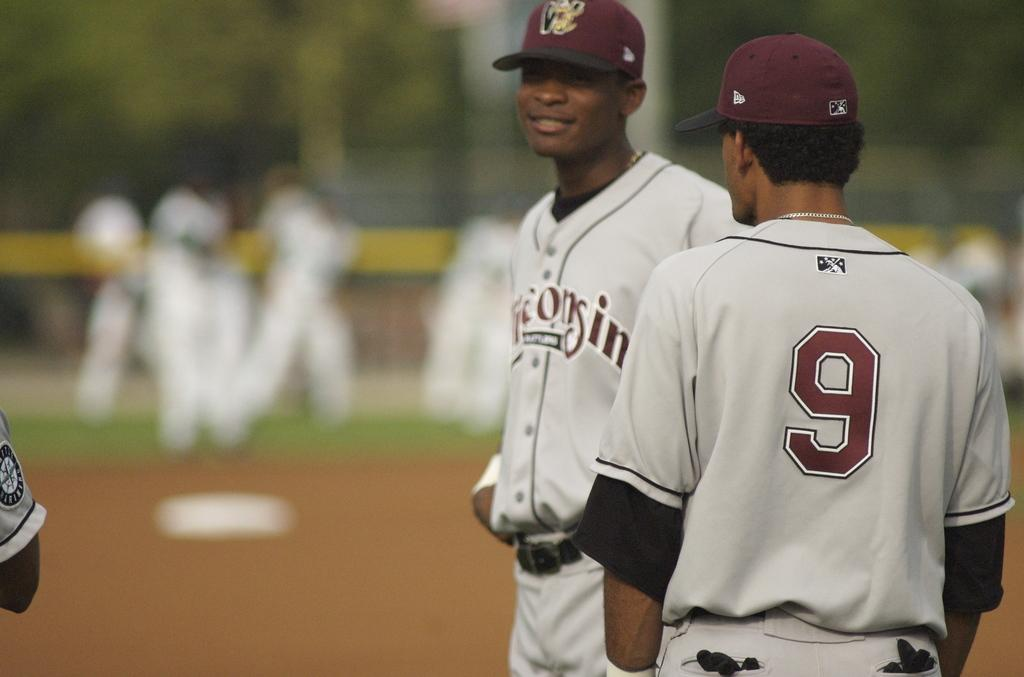<image>
Offer a succinct explanation of the picture presented. Two baseball players, one with a shirt that has the number 9 on the back. 